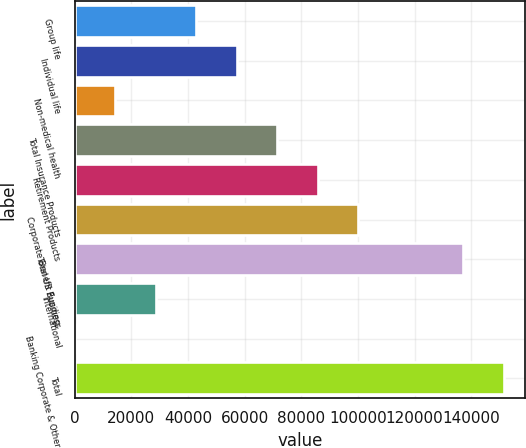Convert chart. <chart><loc_0><loc_0><loc_500><loc_500><bar_chart><fcel>Group life<fcel>Individual life<fcel>Non-medical health<fcel>Total Insurance Products<fcel>Retirement Products<fcel>Corporate Benefit Funding<fcel>Total US Business<fcel>International<fcel>Banking Corporate & Other<fcel>Total<nl><fcel>42922.5<fcel>57208<fcel>14351.5<fcel>71493.5<fcel>85779<fcel>100064<fcel>137201<fcel>28637<fcel>66<fcel>151486<nl></chart> 